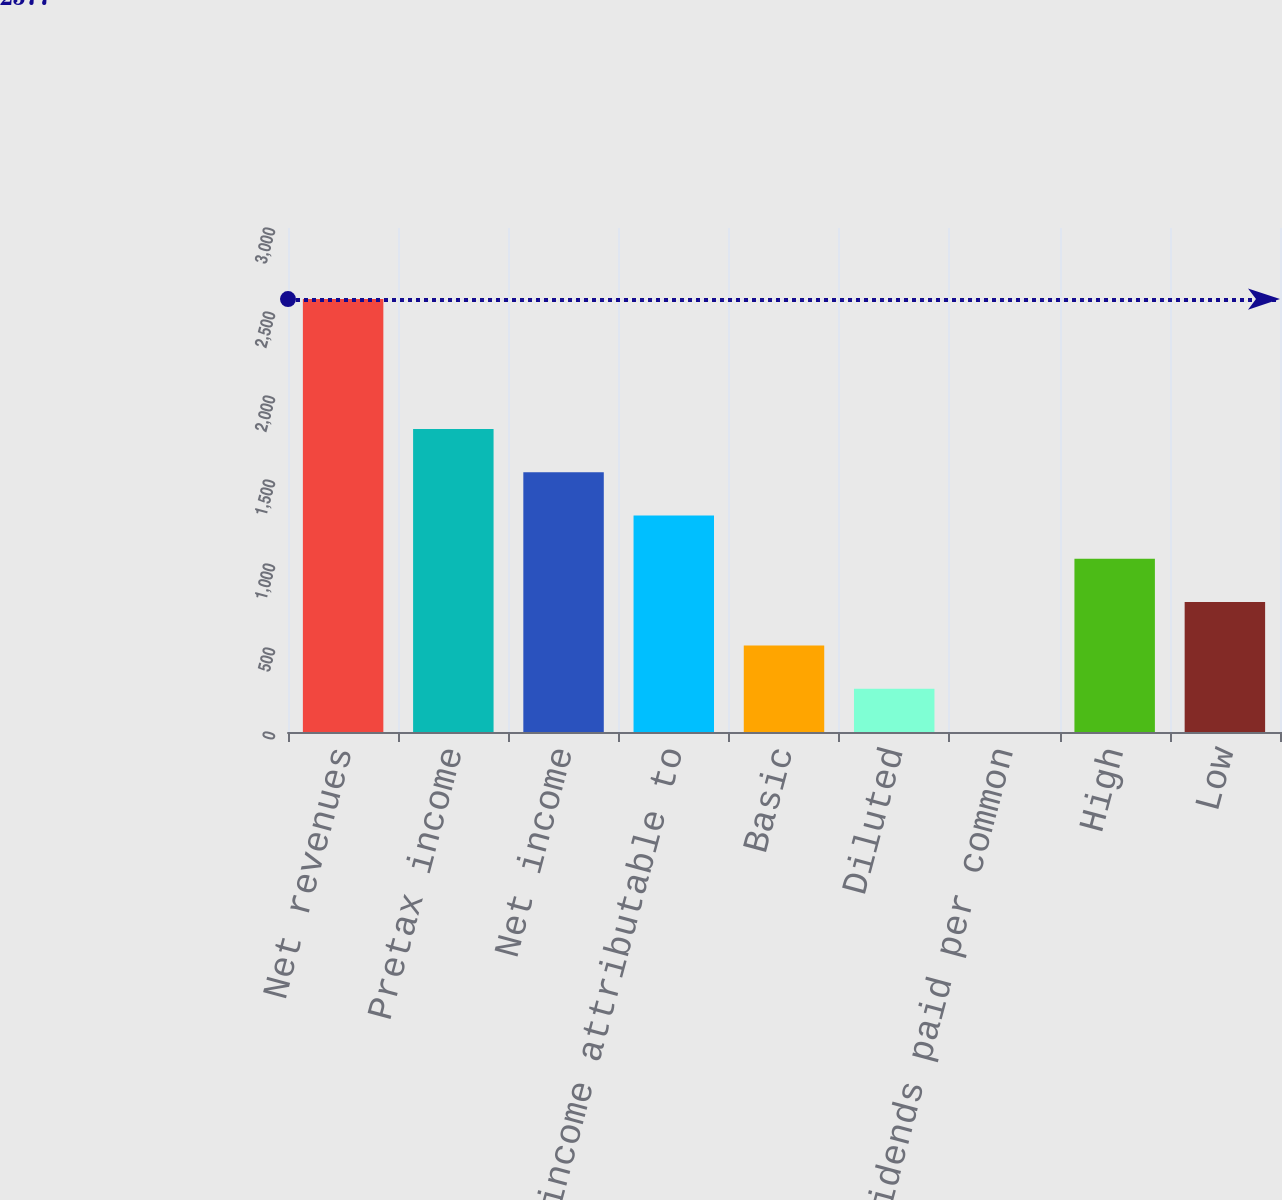Convert chart to OTSL. <chart><loc_0><loc_0><loc_500><loc_500><bar_chart><fcel>Net revenues<fcel>Pretax income<fcel>Net income<fcel>Net income attributable to<fcel>Basic<fcel>Diluted<fcel>Cash dividends paid per common<fcel>High<fcel>Low<nl><fcel>2577<fcel>1803.94<fcel>1546.26<fcel>1288.58<fcel>515.54<fcel>257.86<fcel>0.18<fcel>1030.9<fcel>773.22<nl></chart> 